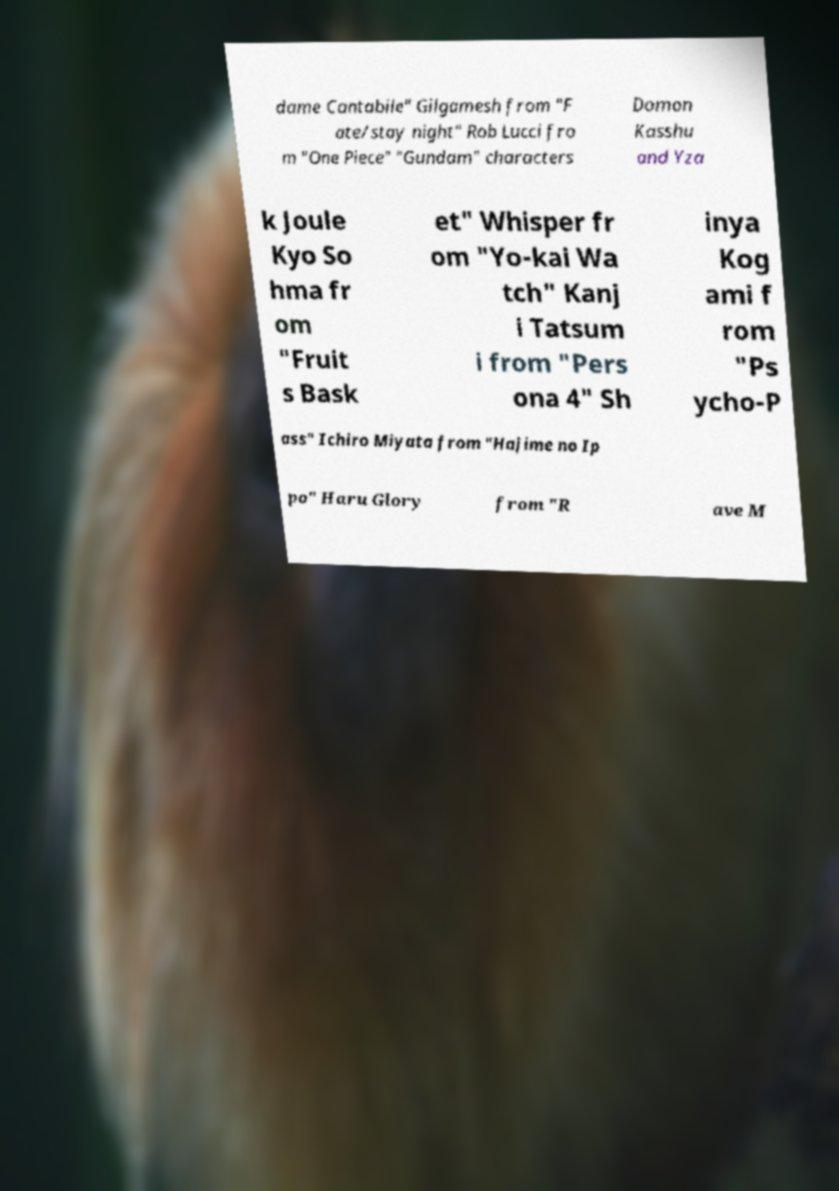Can you read and provide the text displayed in the image?This photo seems to have some interesting text. Can you extract and type it out for me? dame Cantabile" Gilgamesh from "F ate/stay night" Rob Lucci fro m "One Piece" "Gundam" characters Domon Kasshu and Yza k Joule Kyo So hma fr om "Fruit s Bask et" Whisper fr om "Yo-kai Wa tch" Kanj i Tatsum i from "Pers ona 4" Sh inya Kog ami f rom "Ps ycho-P ass" Ichiro Miyata from "Hajime no Ip po" Haru Glory from "R ave M 